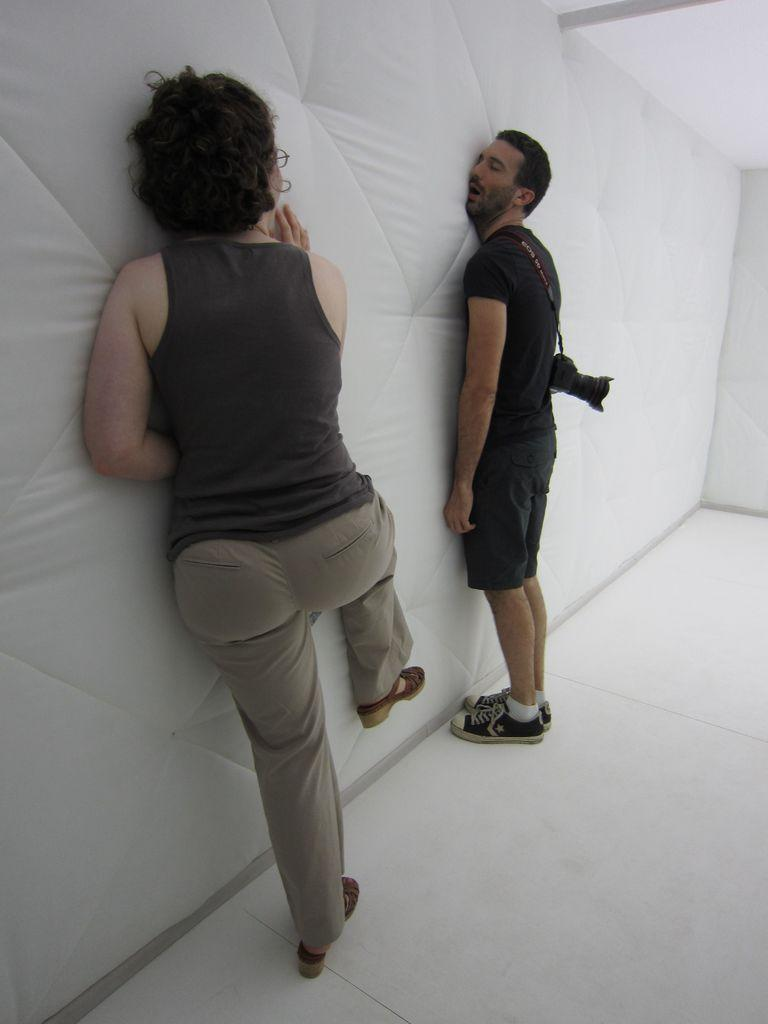How many people are in the image? There are two people in the image. What colors are the people wearing? The people are wearing black, grey, and ash color dresses. Can you describe any accessories or equipment the people are using? One person is wearing a camera. What is visible in the background of the image? There is a white color surface in the background of the image. What type of food can be seen on the coast in the image? There is no food or coast present in the image; it features two people wearing black, grey, and ash color dresses, one of whom is wearing a camera, against a white color background. 